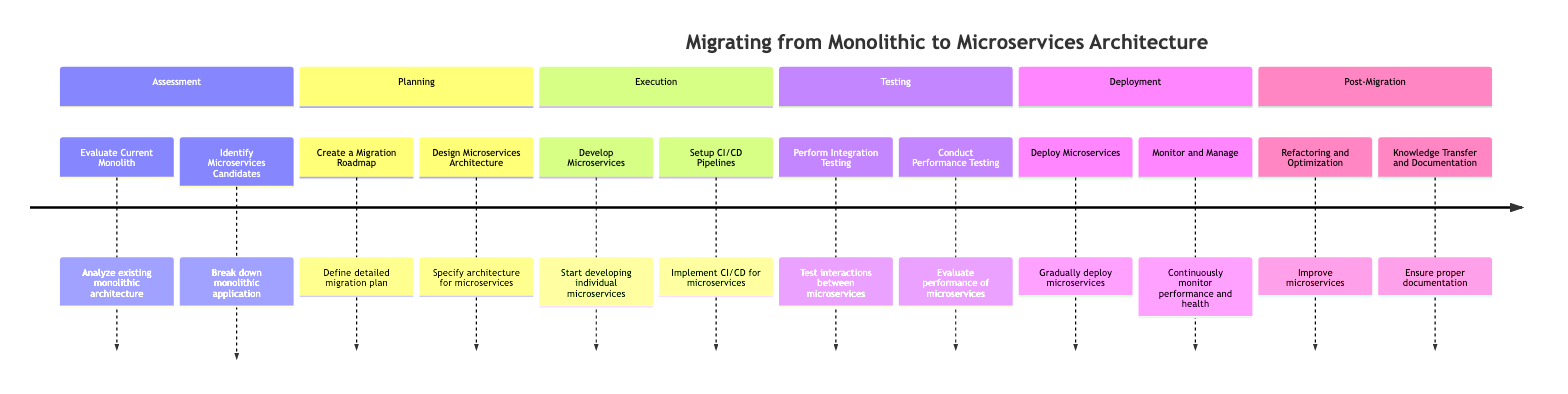What is the first phase in the migration process? The diagram indicates that the first phase listed is "Assessment." This can be directly observed from the initial section of the timeline, which starts with "Assessment."
Answer: Assessment How many tasks are listed in the "Execution" phase? By reviewing the "Execution" section, I can see there are two tasks listed: "Develop Microservices" and "Setup CI/CD Pipelines." Therefore, the total count of tasks is two.
Answer: 2 Which task is focused on testing performance? Looking at the "Testing" section, the task that is directly related to performance is "Conduct Performance Testing." This task is specifically named in the timeline.
Answer: Conduct Performance Testing What is the last task mentioned in the migration timeline? The last task in the timeline is found in the "Post-Migration" phase. It is "Knowledge Transfer and Documentation," which is the final item listed when moving through the sections chronologically.
Answer: Knowledge Transfer and Documentation Which phase comes immediately after "Planning"? The timeline indicates that after "Planning," the next phase is "Execution." This can be confirmed by consulting the flow of the phases defined in the diagram.
Answer: Execution What is one challenge faced during the "Deployment" phase? Within the "Deployment" phase, one of the identified challenges is "Coexistence of Monolith and Microservices." This challenge is explicitly mentioned as part of the tasks within this phase.
Answer: Coexistence of Monolith and Microservices Which section contains the task for monitoring performance? The task for monitoring performance is found in the "Deployment" section, specifically under the task "Monitor and Manage." This is directly listed under the relevant phase in the diagram.
Answer: Deployment How many phases are involved in the timeline? The timeline consists of a total of six phases: Assessment, Planning, Execution, Testing, Deployment, and Post-Migration. This total can be confirmed by counting the distinct phases displayed in the diagram.
Answer: 6 What solution is recommended for ensuring data consistency across services? According to the diagram, the recommended solution for ensuring data consistency across services is "Saga or Event-driven architecture for data consistency." This is directly cited as a solution within the "Planning" phase tasks.
Answer: Saga or Event-driven architecture for data consistency 